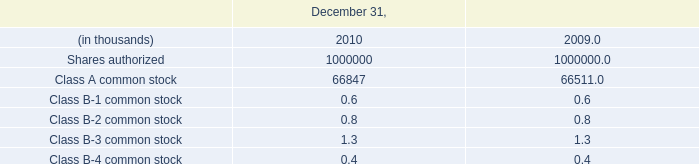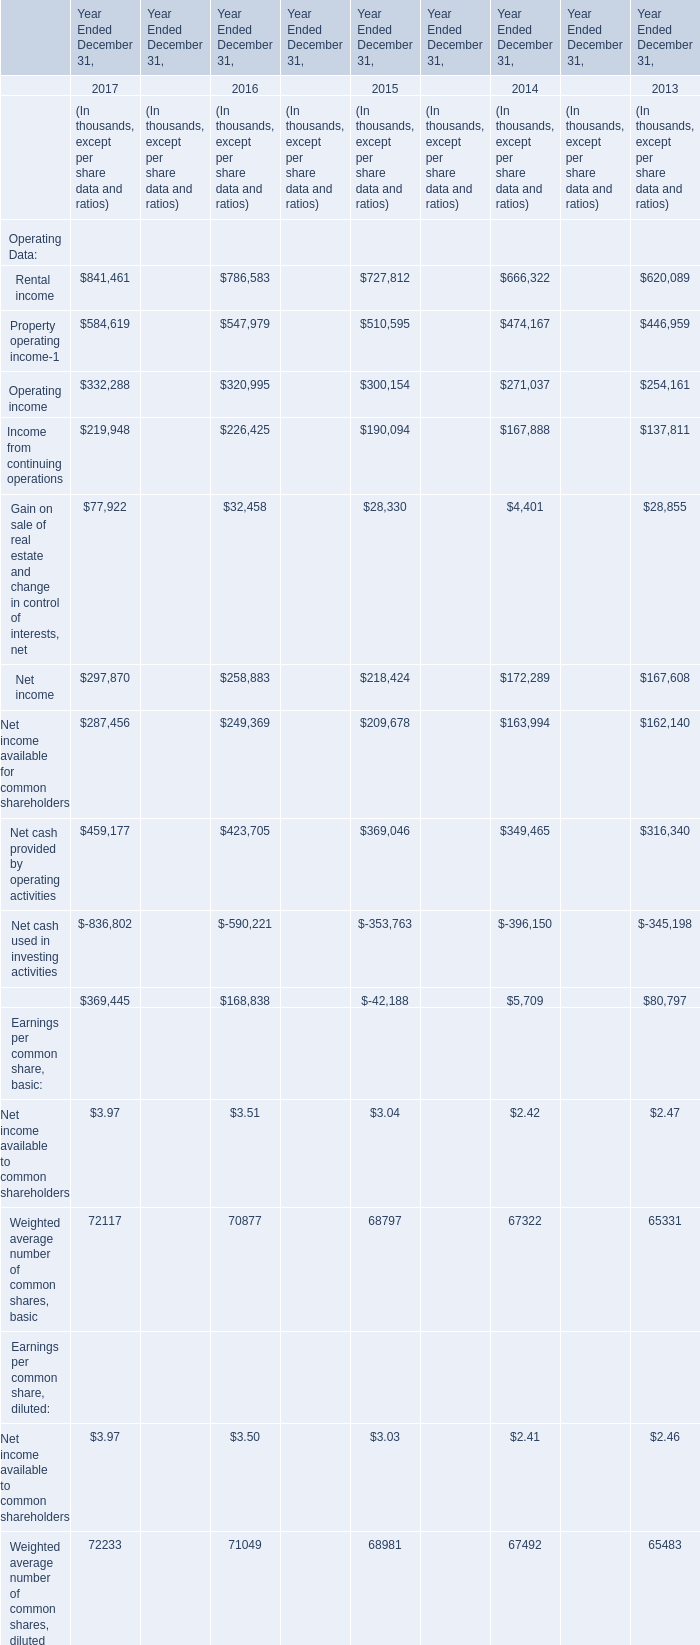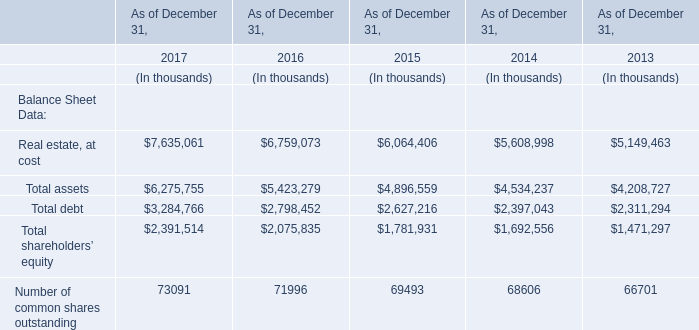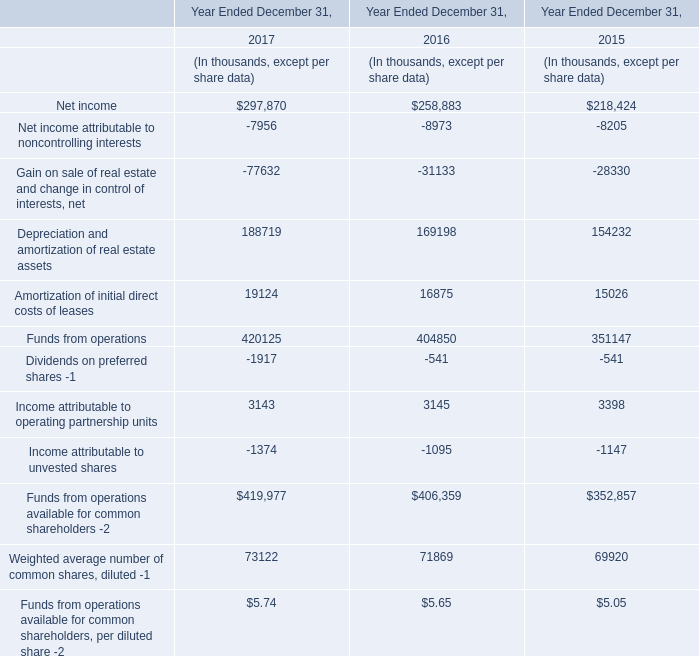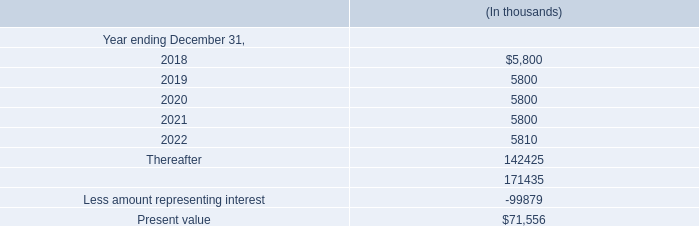What was the average value of Net income, Net income available for common shareholders, Net cash provided by operating activities in 2015 ? (in thousand) 
Computations: (((218424 + 209678) + 369046) / 3)
Answer: 265716.0. 